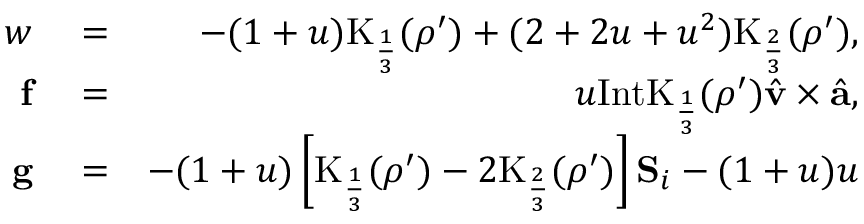<formula> <loc_0><loc_0><loc_500><loc_500>\begin{array} { r l r } { w } & = } & { - ( 1 + u ) K _ { \frac { 1 } { 3 } } ( \rho ^ { \prime } ) + ( 2 + 2 u + u ^ { 2 } ) K _ { \frac { 2 } { 3 } } ( \rho ^ { \prime } ) , } \\ { f } & = } & { u I n t K _ { \frac { 1 } { 3 } } ( \rho ^ { \prime } ) \hat { \mathbf v } \times \hat { \mathbf a } , } \\ { g } & = } & { - ( 1 + u ) \left [ K _ { \frac { 1 } { 3 } } ( \rho ^ { \prime } ) - 2 K _ { \frac { 2 } { 3 } } ( \rho ^ { \prime } ) \right ] S _ { i } - ( 1 + u ) u } \end{array}</formula> 